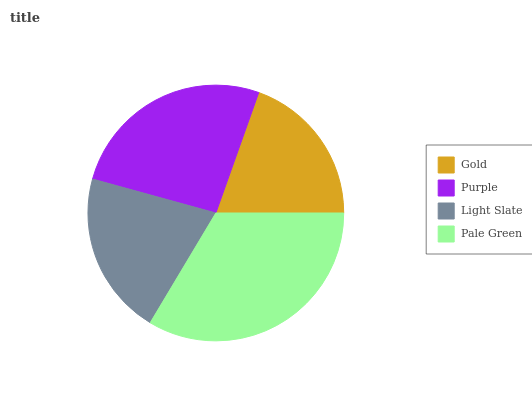Is Gold the minimum?
Answer yes or no. Yes. Is Pale Green the maximum?
Answer yes or no. Yes. Is Purple the minimum?
Answer yes or no. No. Is Purple the maximum?
Answer yes or no. No. Is Purple greater than Gold?
Answer yes or no. Yes. Is Gold less than Purple?
Answer yes or no. Yes. Is Gold greater than Purple?
Answer yes or no. No. Is Purple less than Gold?
Answer yes or no. No. Is Purple the high median?
Answer yes or no. Yes. Is Light Slate the low median?
Answer yes or no. Yes. Is Light Slate the high median?
Answer yes or no. No. Is Pale Green the low median?
Answer yes or no. No. 